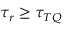Convert formula to latex. <formula><loc_0><loc_0><loc_500><loc_500>\tau _ { r } \geq \tau _ { T Q }</formula> 